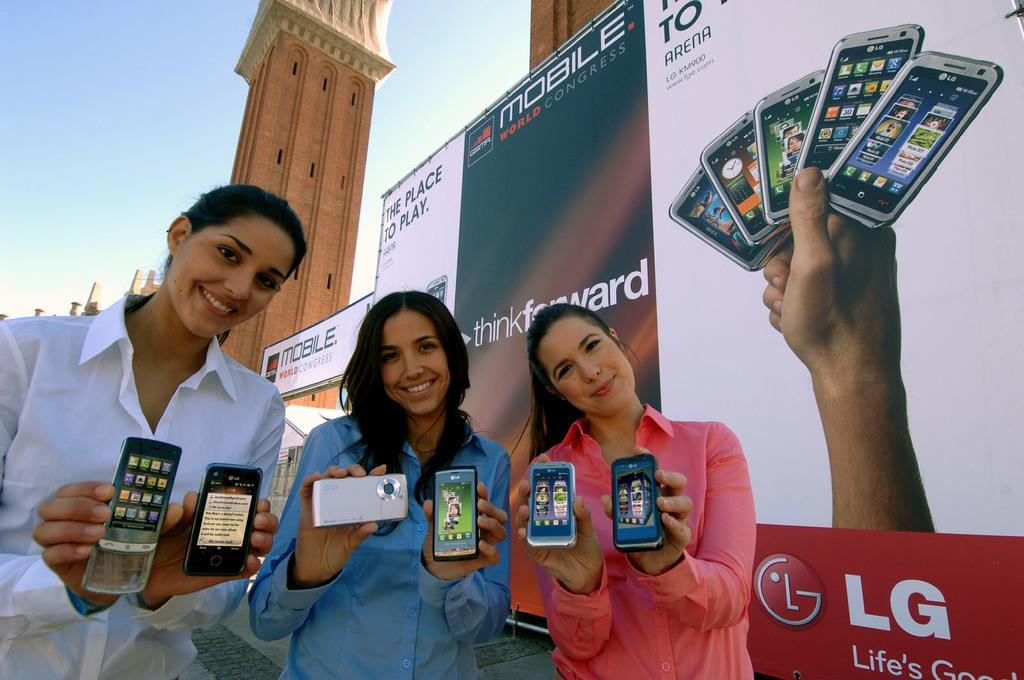How many girls are in the image? There are three girls in the image. What are the girls doing in the image? The girls are standing on the floor and holding mobiles. What can be seen in the background of the image? There is a big poster and a building in the background. How would you describe the weather or lighting in the image? The background is very sunny. How many goldfish are swimming in the image? There are no goldfish present in the image. What type of addition problem can be solved using the information in the image? The image does not contain any information that would allow for solving an addition problem. 